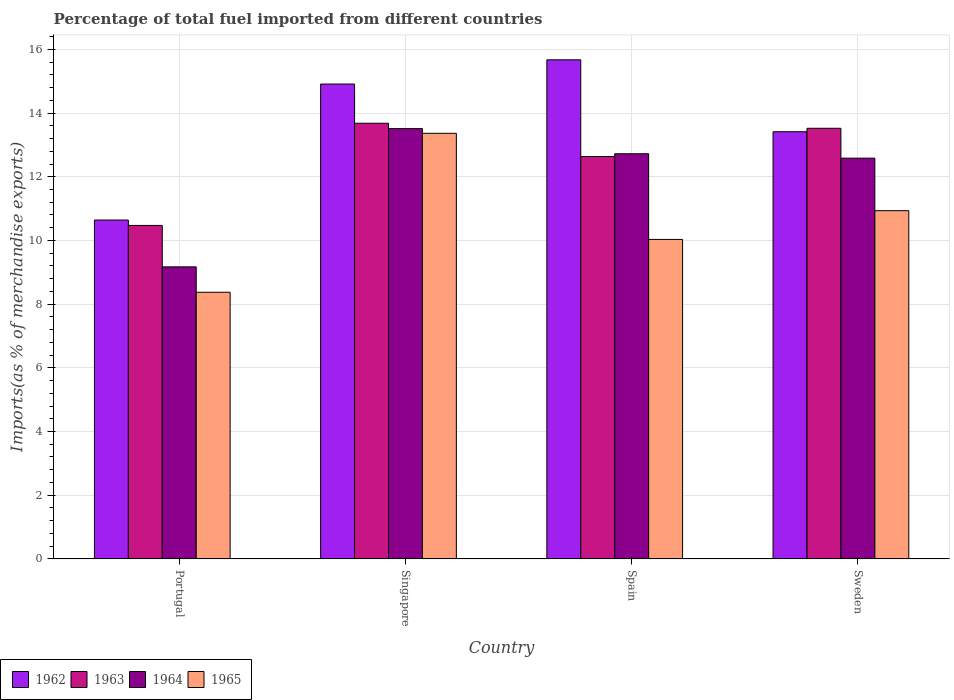How many different coloured bars are there?
Offer a very short reply. 4. Are the number of bars on each tick of the X-axis equal?
Your answer should be very brief. Yes. How many bars are there on the 1st tick from the left?
Your answer should be compact. 4. In how many cases, is the number of bars for a given country not equal to the number of legend labels?
Your response must be concise. 0. What is the percentage of imports to different countries in 1964 in Singapore?
Provide a short and direct response. 13.51. Across all countries, what is the maximum percentage of imports to different countries in 1963?
Provide a short and direct response. 13.68. Across all countries, what is the minimum percentage of imports to different countries in 1963?
Provide a short and direct response. 10.47. In which country was the percentage of imports to different countries in 1963 maximum?
Make the answer very short. Singapore. In which country was the percentage of imports to different countries in 1965 minimum?
Your response must be concise. Portugal. What is the total percentage of imports to different countries in 1962 in the graph?
Your answer should be very brief. 54.64. What is the difference between the percentage of imports to different countries in 1965 in Portugal and that in Spain?
Provide a short and direct response. -1.66. What is the difference between the percentage of imports to different countries in 1963 in Spain and the percentage of imports to different countries in 1964 in Singapore?
Ensure brevity in your answer.  -0.88. What is the average percentage of imports to different countries in 1963 per country?
Ensure brevity in your answer.  12.58. What is the difference between the percentage of imports to different countries of/in 1962 and percentage of imports to different countries of/in 1963 in Spain?
Offer a terse response. 3.04. What is the ratio of the percentage of imports to different countries in 1964 in Portugal to that in Sweden?
Keep it short and to the point. 0.73. Is the difference between the percentage of imports to different countries in 1962 in Singapore and Spain greater than the difference between the percentage of imports to different countries in 1963 in Singapore and Spain?
Give a very brief answer. No. What is the difference between the highest and the second highest percentage of imports to different countries in 1962?
Provide a short and direct response. -1.5. What is the difference between the highest and the lowest percentage of imports to different countries in 1964?
Provide a short and direct response. 4.34. In how many countries, is the percentage of imports to different countries in 1962 greater than the average percentage of imports to different countries in 1962 taken over all countries?
Your answer should be very brief. 2. What does the 4th bar from the left in Singapore represents?
Your answer should be very brief. 1965. Is it the case that in every country, the sum of the percentage of imports to different countries in 1962 and percentage of imports to different countries in 1963 is greater than the percentage of imports to different countries in 1964?
Give a very brief answer. Yes. Are all the bars in the graph horizontal?
Provide a short and direct response. No. How many countries are there in the graph?
Make the answer very short. 4. Does the graph contain any zero values?
Keep it short and to the point. No. Where does the legend appear in the graph?
Ensure brevity in your answer.  Bottom left. What is the title of the graph?
Offer a terse response. Percentage of total fuel imported from different countries. What is the label or title of the Y-axis?
Give a very brief answer. Imports(as % of merchandise exports). What is the Imports(as % of merchandise exports) in 1962 in Portugal?
Your answer should be very brief. 10.64. What is the Imports(as % of merchandise exports) in 1963 in Portugal?
Offer a terse response. 10.47. What is the Imports(as % of merchandise exports) in 1964 in Portugal?
Keep it short and to the point. 9.17. What is the Imports(as % of merchandise exports) in 1965 in Portugal?
Offer a very short reply. 8.37. What is the Imports(as % of merchandise exports) of 1962 in Singapore?
Provide a short and direct response. 14.91. What is the Imports(as % of merchandise exports) of 1963 in Singapore?
Offer a terse response. 13.68. What is the Imports(as % of merchandise exports) in 1964 in Singapore?
Offer a very short reply. 13.51. What is the Imports(as % of merchandise exports) in 1965 in Singapore?
Your response must be concise. 13.37. What is the Imports(as % of merchandise exports) of 1962 in Spain?
Keep it short and to the point. 15.67. What is the Imports(as % of merchandise exports) in 1963 in Spain?
Your answer should be compact. 12.64. What is the Imports(as % of merchandise exports) in 1964 in Spain?
Offer a terse response. 12.72. What is the Imports(as % of merchandise exports) in 1965 in Spain?
Ensure brevity in your answer.  10.03. What is the Imports(as % of merchandise exports) of 1962 in Sweden?
Ensure brevity in your answer.  13.42. What is the Imports(as % of merchandise exports) of 1963 in Sweden?
Provide a short and direct response. 13.52. What is the Imports(as % of merchandise exports) of 1964 in Sweden?
Offer a very short reply. 12.58. What is the Imports(as % of merchandise exports) in 1965 in Sweden?
Offer a very short reply. 10.93. Across all countries, what is the maximum Imports(as % of merchandise exports) in 1962?
Your answer should be very brief. 15.67. Across all countries, what is the maximum Imports(as % of merchandise exports) in 1963?
Make the answer very short. 13.68. Across all countries, what is the maximum Imports(as % of merchandise exports) in 1964?
Your answer should be compact. 13.51. Across all countries, what is the maximum Imports(as % of merchandise exports) in 1965?
Provide a short and direct response. 13.37. Across all countries, what is the minimum Imports(as % of merchandise exports) of 1962?
Offer a terse response. 10.64. Across all countries, what is the minimum Imports(as % of merchandise exports) in 1963?
Offer a terse response. 10.47. Across all countries, what is the minimum Imports(as % of merchandise exports) of 1964?
Provide a short and direct response. 9.17. Across all countries, what is the minimum Imports(as % of merchandise exports) in 1965?
Your answer should be very brief. 8.37. What is the total Imports(as % of merchandise exports) in 1962 in the graph?
Your response must be concise. 54.64. What is the total Imports(as % of merchandise exports) in 1963 in the graph?
Offer a very short reply. 50.31. What is the total Imports(as % of merchandise exports) of 1964 in the graph?
Your answer should be compact. 47.99. What is the total Imports(as % of merchandise exports) of 1965 in the graph?
Your response must be concise. 42.71. What is the difference between the Imports(as % of merchandise exports) in 1962 in Portugal and that in Singapore?
Offer a very short reply. -4.27. What is the difference between the Imports(as % of merchandise exports) of 1963 in Portugal and that in Singapore?
Your answer should be compact. -3.21. What is the difference between the Imports(as % of merchandise exports) of 1964 in Portugal and that in Singapore?
Offer a terse response. -4.34. What is the difference between the Imports(as % of merchandise exports) of 1965 in Portugal and that in Singapore?
Ensure brevity in your answer.  -4.99. What is the difference between the Imports(as % of merchandise exports) in 1962 in Portugal and that in Spain?
Your answer should be very brief. -5.03. What is the difference between the Imports(as % of merchandise exports) in 1963 in Portugal and that in Spain?
Your answer should be compact. -2.16. What is the difference between the Imports(as % of merchandise exports) in 1964 in Portugal and that in Spain?
Your response must be concise. -3.55. What is the difference between the Imports(as % of merchandise exports) of 1965 in Portugal and that in Spain?
Offer a very short reply. -1.66. What is the difference between the Imports(as % of merchandise exports) of 1962 in Portugal and that in Sweden?
Ensure brevity in your answer.  -2.77. What is the difference between the Imports(as % of merchandise exports) in 1963 in Portugal and that in Sweden?
Your response must be concise. -3.05. What is the difference between the Imports(as % of merchandise exports) of 1964 in Portugal and that in Sweden?
Provide a short and direct response. -3.41. What is the difference between the Imports(as % of merchandise exports) in 1965 in Portugal and that in Sweden?
Offer a terse response. -2.56. What is the difference between the Imports(as % of merchandise exports) in 1962 in Singapore and that in Spain?
Ensure brevity in your answer.  -0.76. What is the difference between the Imports(as % of merchandise exports) in 1963 in Singapore and that in Spain?
Your answer should be compact. 1.05. What is the difference between the Imports(as % of merchandise exports) of 1964 in Singapore and that in Spain?
Offer a very short reply. 0.79. What is the difference between the Imports(as % of merchandise exports) of 1965 in Singapore and that in Spain?
Your response must be concise. 3.33. What is the difference between the Imports(as % of merchandise exports) of 1962 in Singapore and that in Sweden?
Keep it short and to the point. 1.5. What is the difference between the Imports(as % of merchandise exports) of 1963 in Singapore and that in Sweden?
Your answer should be compact. 0.16. What is the difference between the Imports(as % of merchandise exports) of 1964 in Singapore and that in Sweden?
Give a very brief answer. 0.93. What is the difference between the Imports(as % of merchandise exports) of 1965 in Singapore and that in Sweden?
Provide a succinct answer. 2.43. What is the difference between the Imports(as % of merchandise exports) in 1962 in Spain and that in Sweden?
Offer a very short reply. 2.26. What is the difference between the Imports(as % of merchandise exports) of 1963 in Spain and that in Sweden?
Keep it short and to the point. -0.89. What is the difference between the Imports(as % of merchandise exports) of 1964 in Spain and that in Sweden?
Your answer should be compact. 0.14. What is the difference between the Imports(as % of merchandise exports) of 1965 in Spain and that in Sweden?
Offer a terse response. -0.9. What is the difference between the Imports(as % of merchandise exports) of 1962 in Portugal and the Imports(as % of merchandise exports) of 1963 in Singapore?
Offer a terse response. -3.04. What is the difference between the Imports(as % of merchandise exports) of 1962 in Portugal and the Imports(as % of merchandise exports) of 1964 in Singapore?
Your answer should be compact. -2.87. What is the difference between the Imports(as % of merchandise exports) of 1962 in Portugal and the Imports(as % of merchandise exports) of 1965 in Singapore?
Ensure brevity in your answer.  -2.72. What is the difference between the Imports(as % of merchandise exports) of 1963 in Portugal and the Imports(as % of merchandise exports) of 1964 in Singapore?
Offer a terse response. -3.04. What is the difference between the Imports(as % of merchandise exports) of 1963 in Portugal and the Imports(as % of merchandise exports) of 1965 in Singapore?
Ensure brevity in your answer.  -2.89. What is the difference between the Imports(as % of merchandise exports) in 1964 in Portugal and the Imports(as % of merchandise exports) in 1965 in Singapore?
Keep it short and to the point. -4.19. What is the difference between the Imports(as % of merchandise exports) of 1962 in Portugal and the Imports(as % of merchandise exports) of 1963 in Spain?
Provide a short and direct response. -1.99. What is the difference between the Imports(as % of merchandise exports) of 1962 in Portugal and the Imports(as % of merchandise exports) of 1964 in Spain?
Keep it short and to the point. -2.08. What is the difference between the Imports(as % of merchandise exports) in 1962 in Portugal and the Imports(as % of merchandise exports) in 1965 in Spain?
Make the answer very short. 0.61. What is the difference between the Imports(as % of merchandise exports) of 1963 in Portugal and the Imports(as % of merchandise exports) of 1964 in Spain?
Your answer should be very brief. -2.25. What is the difference between the Imports(as % of merchandise exports) in 1963 in Portugal and the Imports(as % of merchandise exports) in 1965 in Spain?
Make the answer very short. 0.44. What is the difference between the Imports(as % of merchandise exports) in 1964 in Portugal and the Imports(as % of merchandise exports) in 1965 in Spain?
Make the answer very short. -0.86. What is the difference between the Imports(as % of merchandise exports) of 1962 in Portugal and the Imports(as % of merchandise exports) of 1963 in Sweden?
Your answer should be very brief. -2.88. What is the difference between the Imports(as % of merchandise exports) of 1962 in Portugal and the Imports(as % of merchandise exports) of 1964 in Sweden?
Your response must be concise. -1.94. What is the difference between the Imports(as % of merchandise exports) of 1962 in Portugal and the Imports(as % of merchandise exports) of 1965 in Sweden?
Give a very brief answer. -0.29. What is the difference between the Imports(as % of merchandise exports) in 1963 in Portugal and the Imports(as % of merchandise exports) in 1964 in Sweden?
Provide a succinct answer. -2.11. What is the difference between the Imports(as % of merchandise exports) in 1963 in Portugal and the Imports(as % of merchandise exports) in 1965 in Sweden?
Give a very brief answer. -0.46. What is the difference between the Imports(as % of merchandise exports) of 1964 in Portugal and the Imports(as % of merchandise exports) of 1965 in Sweden?
Your answer should be very brief. -1.76. What is the difference between the Imports(as % of merchandise exports) in 1962 in Singapore and the Imports(as % of merchandise exports) in 1963 in Spain?
Give a very brief answer. 2.28. What is the difference between the Imports(as % of merchandise exports) of 1962 in Singapore and the Imports(as % of merchandise exports) of 1964 in Spain?
Provide a succinct answer. 2.19. What is the difference between the Imports(as % of merchandise exports) in 1962 in Singapore and the Imports(as % of merchandise exports) in 1965 in Spain?
Provide a short and direct response. 4.88. What is the difference between the Imports(as % of merchandise exports) of 1963 in Singapore and the Imports(as % of merchandise exports) of 1964 in Spain?
Offer a terse response. 0.96. What is the difference between the Imports(as % of merchandise exports) of 1963 in Singapore and the Imports(as % of merchandise exports) of 1965 in Spain?
Provide a succinct answer. 3.65. What is the difference between the Imports(as % of merchandise exports) in 1964 in Singapore and the Imports(as % of merchandise exports) in 1965 in Spain?
Give a very brief answer. 3.48. What is the difference between the Imports(as % of merchandise exports) of 1962 in Singapore and the Imports(as % of merchandise exports) of 1963 in Sweden?
Make the answer very short. 1.39. What is the difference between the Imports(as % of merchandise exports) in 1962 in Singapore and the Imports(as % of merchandise exports) in 1964 in Sweden?
Ensure brevity in your answer.  2.33. What is the difference between the Imports(as % of merchandise exports) of 1962 in Singapore and the Imports(as % of merchandise exports) of 1965 in Sweden?
Make the answer very short. 3.98. What is the difference between the Imports(as % of merchandise exports) in 1963 in Singapore and the Imports(as % of merchandise exports) in 1964 in Sweden?
Give a very brief answer. 1.1. What is the difference between the Imports(as % of merchandise exports) in 1963 in Singapore and the Imports(as % of merchandise exports) in 1965 in Sweden?
Your answer should be compact. 2.75. What is the difference between the Imports(as % of merchandise exports) in 1964 in Singapore and the Imports(as % of merchandise exports) in 1965 in Sweden?
Make the answer very short. 2.58. What is the difference between the Imports(as % of merchandise exports) of 1962 in Spain and the Imports(as % of merchandise exports) of 1963 in Sweden?
Provide a succinct answer. 2.15. What is the difference between the Imports(as % of merchandise exports) of 1962 in Spain and the Imports(as % of merchandise exports) of 1964 in Sweden?
Give a very brief answer. 3.09. What is the difference between the Imports(as % of merchandise exports) in 1962 in Spain and the Imports(as % of merchandise exports) in 1965 in Sweden?
Your answer should be compact. 4.74. What is the difference between the Imports(as % of merchandise exports) of 1963 in Spain and the Imports(as % of merchandise exports) of 1964 in Sweden?
Provide a succinct answer. 0.05. What is the difference between the Imports(as % of merchandise exports) of 1963 in Spain and the Imports(as % of merchandise exports) of 1965 in Sweden?
Offer a very short reply. 1.7. What is the difference between the Imports(as % of merchandise exports) of 1964 in Spain and the Imports(as % of merchandise exports) of 1965 in Sweden?
Your response must be concise. 1.79. What is the average Imports(as % of merchandise exports) of 1962 per country?
Provide a short and direct response. 13.66. What is the average Imports(as % of merchandise exports) in 1963 per country?
Offer a terse response. 12.58. What is the average Imports(as % of merchandise exports) in 1964 per country?
Your answer should be compact. 12. What is the average Imports(as % of merchandise exports) in 1965 per country?
Offer a very short reply. 10.68. What is the difference between the Imports(as % of merchandise exports) of 1962 and Imports(as % of merchandise exports) of 1963 in Portugal?
Ensure brevity in your answer.  0.17. What is the difference between the Imports(as % of merchandise exports) of 1962 and Imports(as % of merchandise exports) of 1964 in Portugal?
Make the answer very short. 1.47. What is the difference between the Imports(as % of merchandise exports) in 1962 and Imports(as % of merchandise exports) in 1965 in Portugal?
Your answer should be compact. 2.27. What is the difference between the Imports(as % of merchandise exports) of 1963 and Imports(as % of merchandise exports) of 1964 in Portugal?
Ensure brevity in your answer.  1.3. What is the difference between the Imports(as % of merchandise exports) in 1963 and Imports(as % of merchandise exports) in 1965 in Portugal?
Offer a very short reply. 2.1. What is the difference between the Imports(as % of merchandise exports) in 1964 and Imports(as % of merchandise exports) in 1965 in Portugal?
Ensure brevity in your answer.  0.8. What is the difference between the Imports(as % of merchandise exports) in 1962 and Imports(as % of merchandise exports) in 1963 in Singapore?
Give a very brief answer. 1.23. What is the difference between the Imports(as % of merchandise exports) of 1962 and Imports(as % of merchandise exports) of 1964 in Singapore?
Offer a very short reply. 1.4. What is the difference between the Imports(as % of merchandise exports) of 1962 and Imports(as % of merchandise exports) of 1965 in Singapore?
Your response must be concise. 1.55. What is the difference between the Imports(as % of merchandise exports) of 1963 and Imports(as % of merchandise exports) of 1964 in Singapore?
Make the answer very short. 0.17. What is the difference between the Imports(as % of merchandise exports) in 1963 and Imports(as % of merchandise exports) in 1965 in Singapore?
Keep it short and to the point. 0.32. What is the difference between the Imports(as % of merchandise exports) in 1964 and Imports(as % of merchandise exports) in 1965 in Singapore?
Ensure brevity in your answer.  0.15. What is the difference between the Imports(as % of merchandise exports) of 1962 and Imports(as % of merchandise exports) of 1963 in Spain?
Ensure brevity in your answer.  3.04. What is the difference between the Imports(as % of merchandise exports) of 1962 and Imports(as % of merchandise exports) of 1964 in Spain?
Offer a terse response. 2.95. What is the difference between the Imports(as % of merchandise exports) in 1962 and Imports(as % of merchandise exports) in 1965 in Spain?
Make the answer very short. 5.64. What is the difference between the Imports(as % of merchandise exports) of 1963 and Imports(as % of merchandise exports) of 1964 in Spain?
Offer a terse response. -0.09. What is the difference between the Imports(as % of merchandise exports) in 1963 and Imports(as % of merchandise exports) in 1965 in Spain?
Provide a succinct answer. 2.6. What is the difference between the Imports(as % of merchandise exports) in 1964 and Imports(as % of merchandise exports) in 1965 in Spain?
Your answer should be very brief. 2.69. What is the difference between the Imports(as % of merchandise exports) in 1962 and Imports(as % of merchandise exports) in 1963 in Sweden?
Offer a very short reply. -0.11. What is the difference between the Imports(as % of merchandise exports) in 1962 and Imports(as % of merchandise exports) in 1964 in Sweden?
Your response must be concise. 0.83. What is the difference between the Imports(as % of merchandise exports) of 1962 and Imports(as % of merchandise exports) of 1965 in Sweden?
Your answer should be very brief. 2.48. What is the difference between the Imports(as % of merchandise exports) of 1963 and Imports(as % of merchandise exports) of 1964 in Sweden?
Make the answer very short. 0.94. What is the difference between the Imports(as % of merchandise exports) in 1963 and Imports(as % of merchandise exports) in 1965 in Sweden?
Provide a succinct answer. 2.59. What is the difference between the Imports(as % of merchandise exports) in 1964 and Imports(as % of merchandise exports) in 1965 in Sweden?
Ensure brevity in your answer.  1.65. What is the ratio of the Imports(as % of merchandise exports) of 1962 in Portugal to that in Singapore?
Offer a very short reply. 0.71. What is the ratio of the Imports(as % of merchandise exports) in 1963 in Portugal to that in Singapore?
Provide a short and direct response. 0.77. What is the ratio of the Imports(as % of merchandise exports) of 1964 in Portugal to that in Singapore?
Make the answer very short. 0.68. What is the ratio of the Imports(as % of merchandise exports) of 1965 in Portugal to that in Singapore?
Provide a short and direct response. 0.63. What is the ratio of the Imports(as % of merchandise exports) of 1962 in Portugal to that in Spain?
Your response must be concise. 0.68. What is the ratio of the Imports(as % of merchandise exports) of 1963 in Portugal to that in Spain?
Your response must be concise. 0.83. What is the ratio of the Imports(as % of merchandise exports) of 1964 in Portugal to that in Spain?
Provide a succinct answer. 0.72. What is the ratio of the Imports(as % of merchandise exports) of 1965 in Portugal to that in Spain?
Ensure brevity in your answer.  0.83. What is the ratio of the Imports(as % of merchandise exports) in 1962 in Portugal to that in Sweden?
Your answer should be very brief. 0.79. What is the ratio of the Imports(as % of merchandise exports) in 1963 in Portugal to that in Sweden?
Ensure brevity in your answer.  0.77. What is the ratio of the Imports(as % of merchandise exports) of 1964 in Portugal to that in Sweden?
Make the answer very short. 0.73. What is the ratio of the Imports(as % of merchandise exports) in 1965 in Portugal to that in Sweden?
Keep it short and to the point. 0.77. What is the ratio of the Imports(as % of merchandise exports) of 1962 in Singapore to that in Spain?
Offer a terse response. 0.95. What is the ratio of the Imports(as % of merchandise exports) in 1963 in Singapore to that in Spain?
Your response must be concise. 1.08. What is the ratio of the Imports(as % of merchandise exports) of 1964 in Singapore to that in Spain?
Make the answer very short. 1.06. What is the ratio of the Imports(as % of merchandise exports) in 1965 in Singapore to that in Spain?
Provide a succinct answer. 1.33. What is the ratio of the Imports(as % of merchandise exports) of 1962 in Singapore to that in Sweden?
Your answer should be compact. 1.11. What is the ratio of the Imports(as % of merchandise exports) in 1963 in Singapore to that in Sweden?
Your answer should be compact. 1.01. What is the ratio of the Imports(as % of merchandise exports) in 1964 in Singapore to that in Sweden?
Keep it short and to the point. 1.07. What is the ratio of the Imports(as % of merchandise exports) of 1965 in Singapore to that in Sweden?
Provide a short and direct response. 1.22. What is the ratio of the Imports(as % of merchandise exports) of 1962 in Spain to that in Sweden?
Offer a terse response. 1.17. What is the ratio of the Imports(as % of merchandise exports) of 1963 in Spain to that in Sweden?
Your answer should be compact. 0.93. What is the ratio of the Imports(as % of merchandise exports) in 1965 in Spain to that in Sweden?
Offer a terse response. 0.92. What is the difference between the highest and the second highest Imports(as % of merchandise exports) in 1962?
Ensure brevity in your answer.  0.76. What is the difference between the highest and the second highest Imports(as % of merchandise exports) of 1963?
Provide a short and direct response. 0.16. What is the difference between the highest and the second highest Imports(as % of merchandise exports) in 1964?
Offer a terse response. 0.79. What is the difference between the highest and the second highest Imports(as % of merchandise exports) of 1965?
Your response must be concise. 2.43. What is the difference between the highest and the lowest Imports(as % of merchandise exports) in 1962?
Make the answer very short. 5.03. What is the difference between the highest and the lowest Imports(as % of merchandise exports) of 1963?
Your response must be concise. 3.21. What is the difference between the highest and the lowest Imports(as % of merchandise exports) in 1964?
Give a very brief answer. 4.34. What is the difference between the highest and the lowest Imports(as % of merchandise exports) in 1965?
Keep it short and to the point. 4.99. 